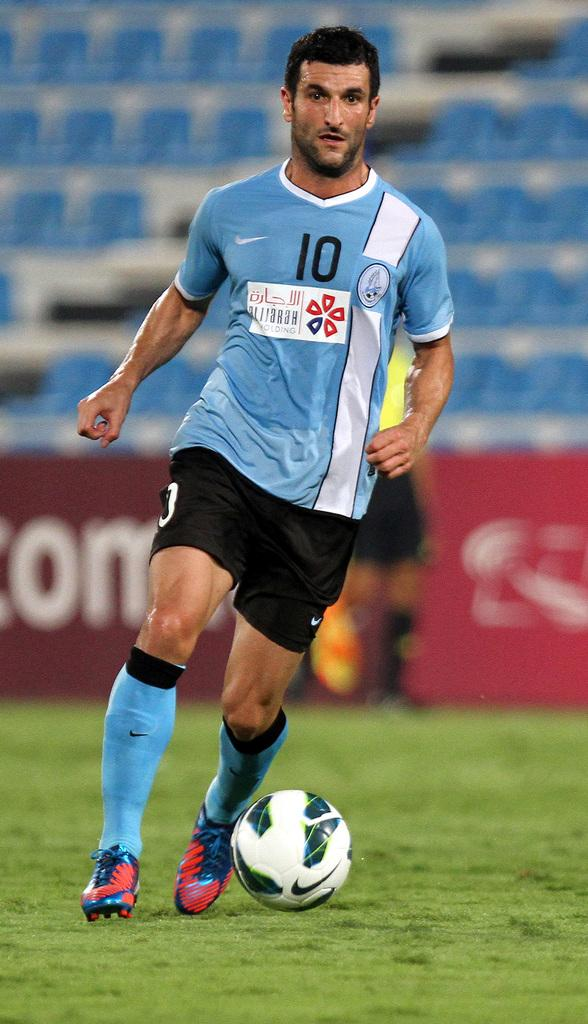What is the main subject of the image? There is a person standing in the center of the image. What activity is the person engaged in? The person is playing football. Where is the football being played? The football is being played on a field. How many scarecrows are visible in the image? There are no scarecrows present in the image. What type of waste can be seen on the field in the image? There is no waste visible in the image; it only shows a person playing football on a field. 